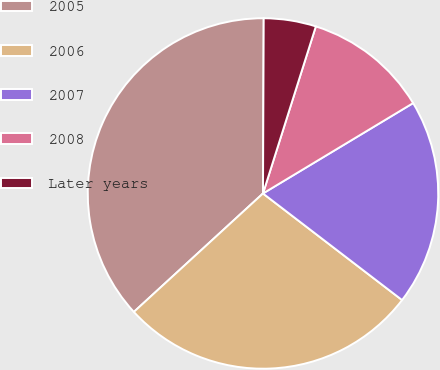<chart> <loc_0><loc_0><loc_500><loc_500><pie_chart><fcel>2005<fcel>2006<fcel>2007<fcel>2008<fcel>Later years<nl><fcel>36.88%<fcel>27.78%<fcel>19.03%<fcel>11.5%<fcel>4.81%<nl></chart> 